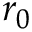Convert formula to latex. <formula><loc_0><loc_0><loc_500><loc_500>r _ { 0 }</formula> 